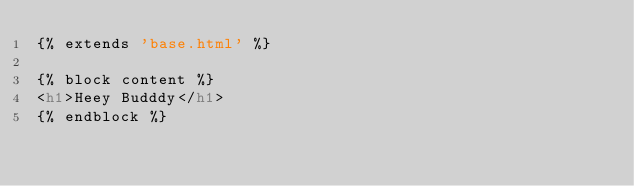Convert code to text. <code><loc_0><loc_0><loc_500><loc_500><_HTML_>{% extends 'base.html' %}

{% block content %}
<h1>Heey Budddy</h1>
{% endblock %}</code> 